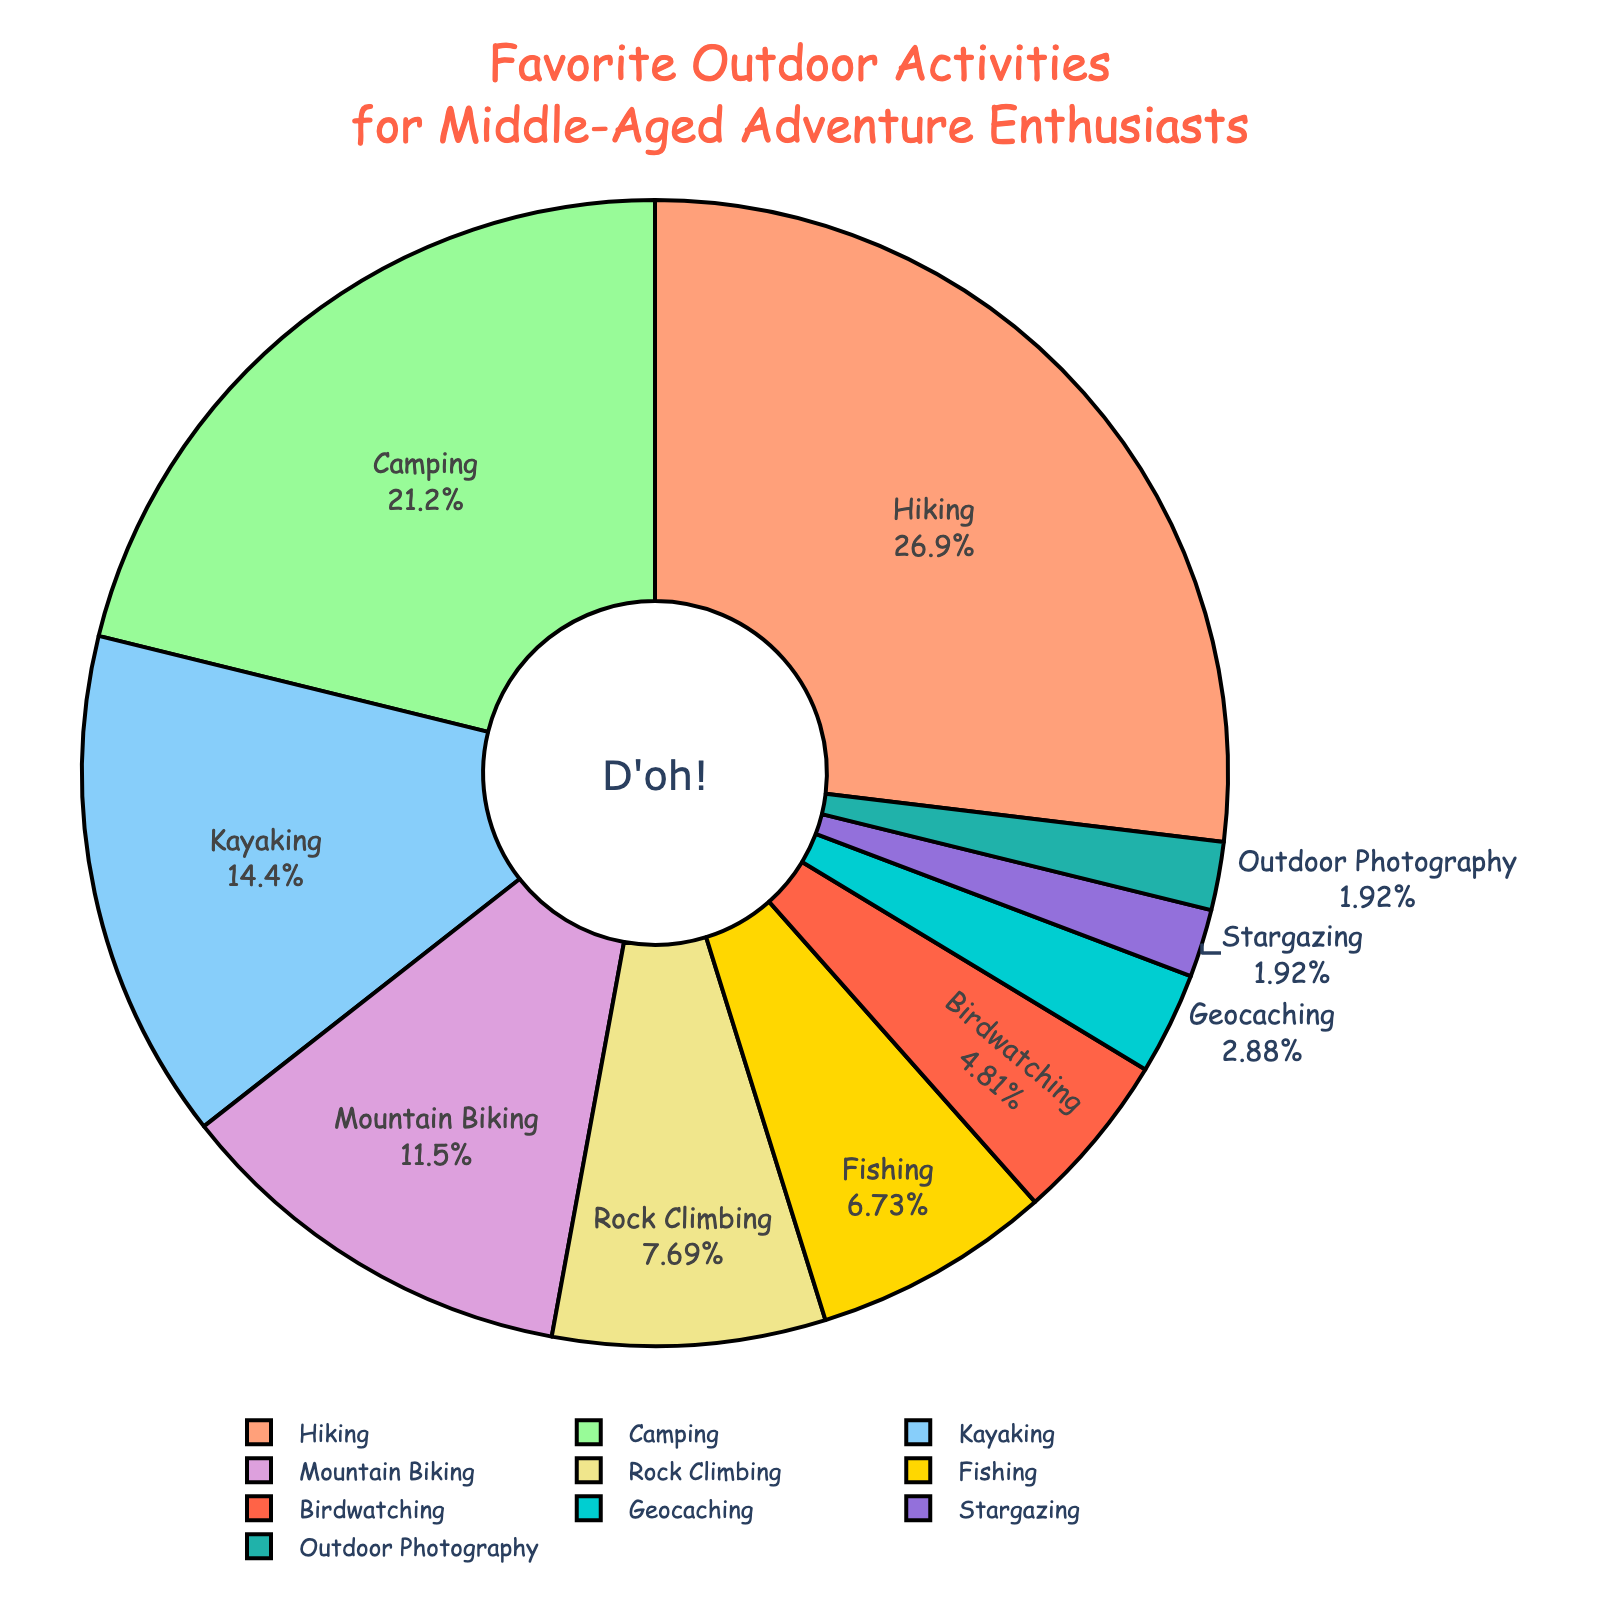what is the most popular outdoor activity among middle-aged adventure enthusiasts? The pie chart shows different activities with their corresponding percentages. Hiking has the largest segment, indicating it's the most popular, at 28%.
Answer: Hiking which activity is more popular, kayaking or mountain biking? Comparing the pie slices for kayaking and mountain biking, kayaking has a larger slice at 15%, while mountain biking is at 12%.
Answer: Kayaking sum of the percentages for camping and rock climbing? The pie chart shows that camping is 22% and rock climbing is 8%. Adding these together gives 22% + 8% = 30%.
Answer: 30% which activities have percentages less than 5%? Looking at the slices, birdwatching, geocaching, stargazing, and outdoor photography each have percentages less than 5%.
Answer: Birdwatching, Geocaching, Stargazing, Outdoor Photography difference in percentage between the most and least popular activities? The most popular activity is hiking at 28% and the least popular are stargazing and outdoor photography each at 2%. The difference is 28% - 2% = 26%.
Answer: 26% what is the total percentage of water-related activities (kayaking and fishing)? According to the pie chart, kayaking is 15% and fishing is 7%. Adding them together, 15% + 7% = 22%.
Answer: 22% are there more people who prefer camping than those who prefer hiking and kayaking combined? The pie chart indicates camping has 22%, hiking has 28%, and kayaking has 15%. Combined, hiking and kayaking have 28% + 15% = 43%, which is greater than 22%.
Answer: No what is the combined percentage for activities with a slice color that is cool-toned (green, light blue, purple, teal)? The cool-toned colors correspond to camping (22%), kayaking (15%), mountain biking (12%), geocaching (3%), and outdoor photography (2%). Summing these percentages gives 22% + 15% + 12% + 3% + 2% = 54%.
Answer: 54% which activity has the smallest percentage? Observing the smallest slices, stargazing and outdoor photography each have the smallest percentages at 2%.
Answer: Stargazing, Outdoor Photography 